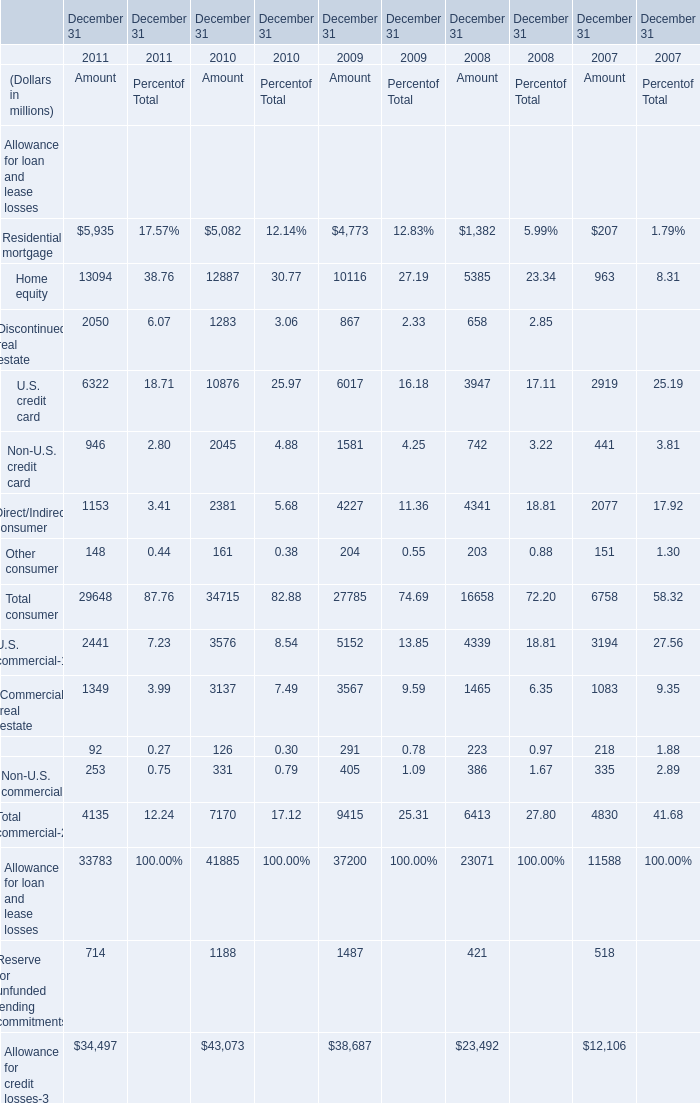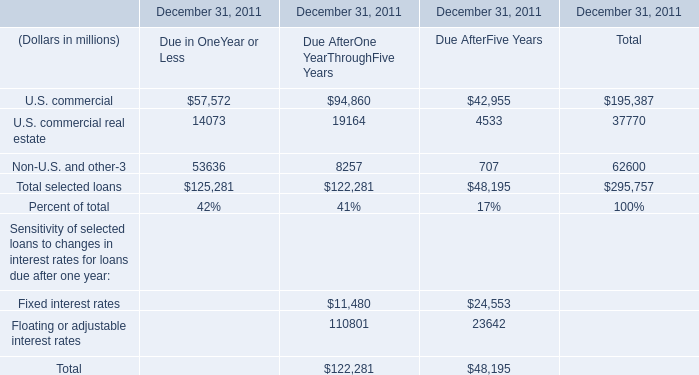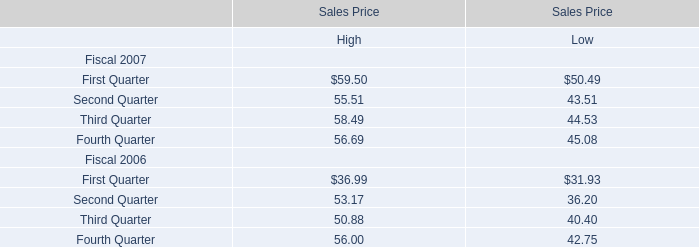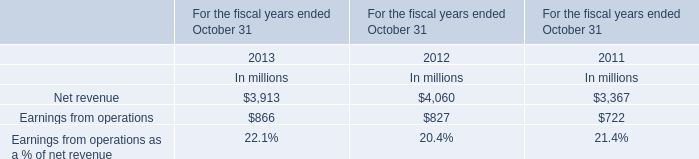What's the total amount of Discontinued real estate, Discontinued real estate ,U.S. credit card and Non-U.S. credit card in 2011? (in million) 
Computations: (((2050 + 6322) + 946) + 1153)
Answer: 10471.0. 